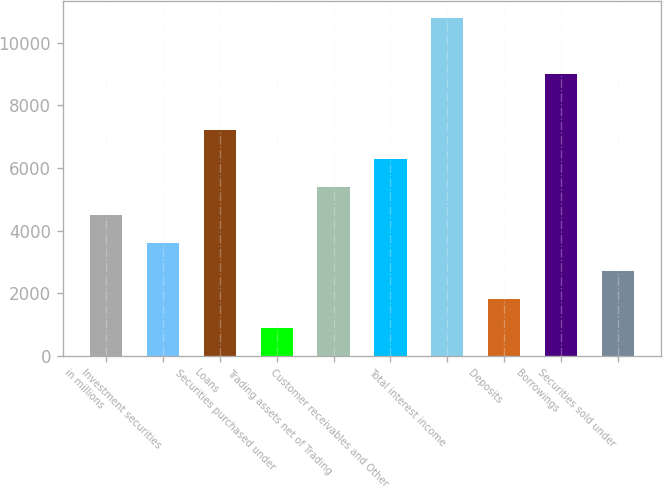Convert chart to OTSL. <chart><loc_0><loc_0><loc_500><loc_500><bar_chart><fcel>in millions<fcel>Investment securities<fcel>Loans<fcel>Securities purchased under<fcel>Trading assets net of Trading<fcel>Customer receivables and Other<fcel>Total interest income<fcel>Deposits<fcel>Borrowings<fcel>Securities sold under<nl><fcel>4504.5<fcel>3606<fcel>7200<fcel>910.5<fcel>5403<fcel>6301.5<fcel>10794<fcel>1809<fcel>8997<fcel>2707.5<nl></chart> 